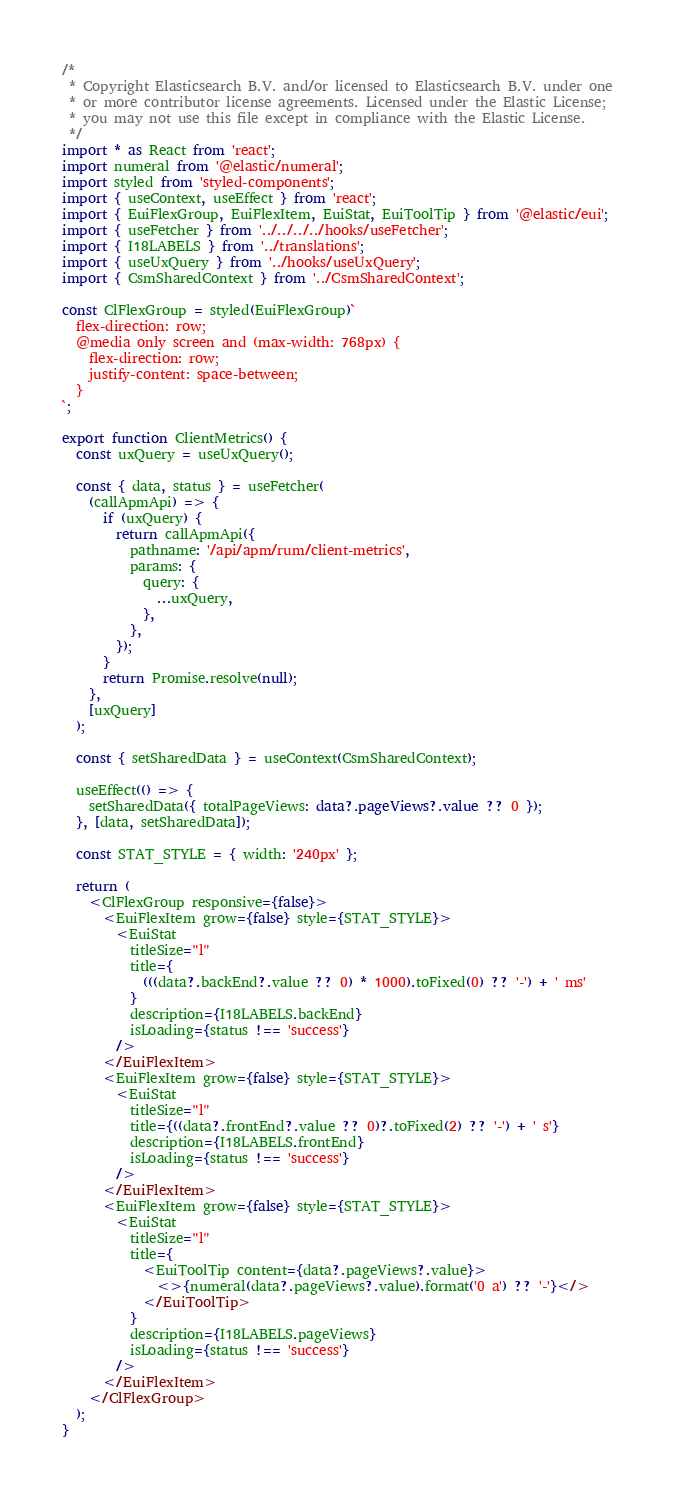Convert code to text. <code><loc_0><loc_0><loc_500><loc_500><_TypeScript_>/*
 * Copyright Elasticsearch B.V. and/or licensed to Elasticsearch B.V. under one
 * or more contributor license agreements. Licensed under the Elastic License;
 * you may not use this file except in compliance with the Elastic License.
 */
import * as React from 'react';
import numeral from '@elastic/numeral';
import styled from 'styled-components';
import { useContext, useEffect } from 'react';
import { EuiFlexGroup, EuiFlexItem, EuiStat, EuiToolTip } from '@elastic/eui';
import { useFetcher } from '../../../../hooks/useFetcher';
import { I18LABELS } from '../translations';
import { useUxQuery } from '../hooks/useUxQuery';
import { CsmSharedContext } from '../CsmSharedContext';

const ClFlexGroup = styled(EuiFlexGroup)`
  flex-direction: row;
  @media only screen and (max-width: 768px) {
    flex-direction: row;
    justify-content: space-between;
  }
`;

export function ClientMetrics() {
  const uxQuery = useUxQuery();

  const { data, status } = useFetcher(
    (callApmApi) => {
      if (uxQuery) {
        return callApmApi({
          pathname: '/api/apm/rum/client-metrics',
          params: {
            query: {
              ...uxQuery,
            },
          },
        });
      }
      return Promise.resolve(null);
    },
    [uxQuery]
  );

  const { setSharedData } = useContext(CsmSharedContext);

  useEffect(() => {
    setSharedData({ totalPageViews: data?.pageViews?.value ?? 0 });
  }, [data, setSharedData]);

  const STAT_STYLE = { width: '240px' };

  return (
    <ClFlexGroup responsive={false}>
      <EuiFlexItem grow={false} style={STAT_STYLE}>
        <EuiStat
          titleSize="l"
          title={
            (((data?.backEnd?.value ?? 0) * 1000).toFixed(0) ?? '-') + ' ms'
          }
          description={I18LABELS.backEnd}
          isLoading={status !== 'success'}
        />
      </EuiFlexItem>
      <EuiFlexItem grow={false} style={STAT_STYLE}>
        <EuiStat
          titleSize="l"
          title={((data?.frontEnd?.value ?? 0)?.toFixed(2) ?? '-') + ' s'}
          description={I18LABELS.frontEnd}
          isLoading={status !== 'success'}
        />
      </EuiFlexItem>
      <EuiFlexItem grow={false} style={STAT_STYLE}>
        <EuiStat
          titleSize="l"
          title={
            <EuiToolTip content={data?.pageViews?.value}>
              <>{numeral(data?.pageViews?.value).format('0 a') ?? '-'}</>
            </EuiToolTip>
          }
          description={I18LABELS.pageViews}
          isLoading={status !== 'success'}
        />
      </EuiFlexItem>
    </ClFlexGroup>
  );
}
</code> 